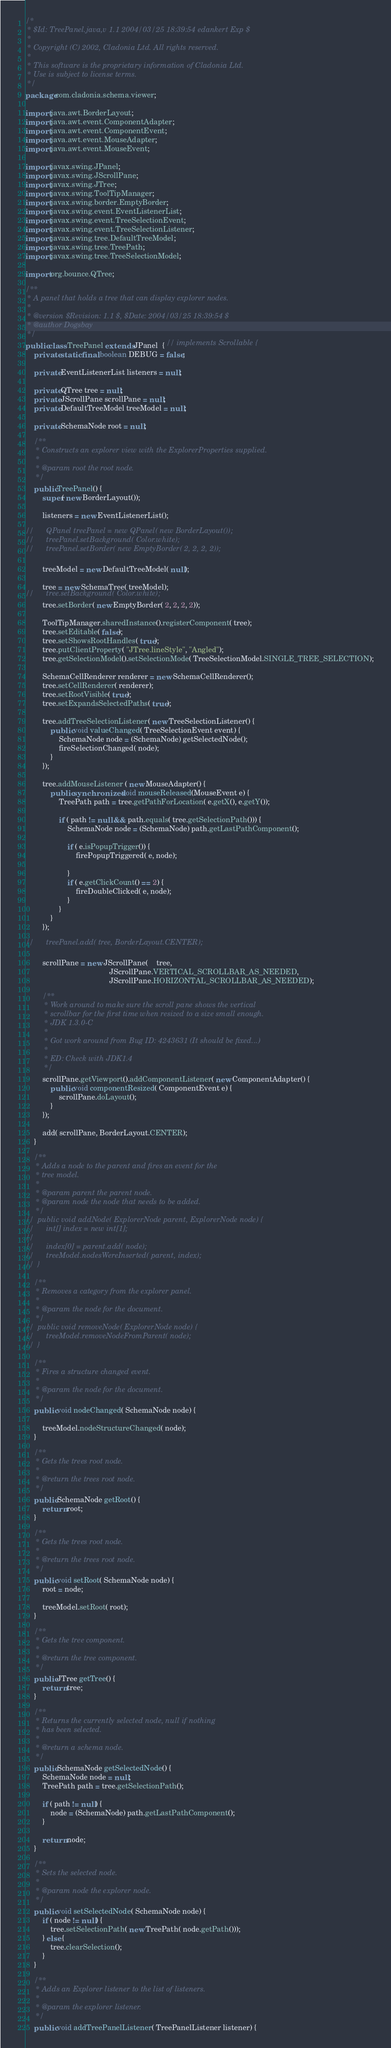<code> <loc_0><loc_0><loc_500><loc_500><_Java_>/*
 * $Id: TreePanel.java,v 1.1 2004/03/25 18:39:54 edankert Exp $
 *
 * Copyright (C) 2002, Cladonia Ltd. All rights reserved.
 *
 * This software is the proprietary information of Cladonia Ltd.  
 * Use is subject to license terms.
 */
package com.cladonia.schema.viewer;

import java.awt.BorderLayout;
import java.awt.event.ComponentAdapter;
import java.awt.event.ComponentEvent;
import java.awt.event.MouseAdapter;
import java.awt.event.MouseEvent;

import javax.swing.JPanel;
import javax.swing.JScrollPane;
import javax.swing.JTree;
import javax.swing.ToolTipManager;
import javax.swing.border.EmptyBorder;
import javax.swing.event.EventListenerList;
import javax.swing.event.TreeSelectionEvent;
import javax.swing.event.TreeSelectionListener;
import javax.swing.tree.DefaultTreeModel;
import javax.swing.tree.TreePath;
import javax.swing.tree.TreeSelectionModel;

import org.bounce.QTree;

/**
 * A panel that holds a tree that can display explorer nodes.
 *
 * @version	$Revision: 1.1 $, $Date: 2004/03/25 18:39:54 $
 * @author Dogsbay
 */
public class TreePanel extends JPanel  { // implements Scrollable {
	private static final boolean DEBUG = false;

	private EventListenerList listeners = null;

	private QTree tree = null;
	private JScrollPane scrollPane = null;
	private DefaultTreeModel treeModel = null;

	private SchemaNode root = null;

	/**
	 * Constructs an explorer view with the ExplorerProperties supplied.
	 *
	 * @param root the root node.
	 */
	public TreePanel() {
		super( new BorderLayout());
		
		listeners = new EventListenerList();
		
//		QPanel treePanel = new QPanel( new BorderLayout());
//		treePanel.setBackground( Color.white);
//		treePanel.setBorder( new EmptyBorder( 2, 2, 2, 2));

		treeModel = new DefaultTreeModel( null);

		tree = new SchemaTree( treeModel);
//		tree.setBackground( Color.white);
		tree.setBorder( new EmptyBorder( 2, 2, 2, 2));
		
		ToolTipManager.sharedInstance().registerComponent( tree);
		tree.setEditable( false);
		tree.setShowsRootHandles( true);
		tree.putClientProperty( "JTree.lineStyle", "Angled");
		tree.getSelectionModel().setSelectionMode( TreeSelectionModel.SINGLE_TREE_SELECTION);

		SchemaCellRenderer renderer = new SchemaCellRenderer();
		tree.setCellRenderer( renderer);
		tree.setRootVisible( true);
		tree.setExpandsSelectedPaths( true);

		tree.addTreeSelectionListener( new TreeSelectionListener() {
			public void valueChanged( TreeSelectionEvent event) {
				SchemaNode node = (SchemaNode) getSelectedNode();
				fireSelectionChanged( node);
			}
		});

		tree.addMouseListener ( new MouseAdapter() {
			public synchronized void mouseReleased(MouseEvent e) {
				TreePath path = tree.getPathForLocation( e.getX(), e.getY());

				if ( path != null && path.equals( tree.getSelectionPath())) {
					SchemaNode node = (SchemaNode) path.getLastPathComponent();
					
					if ( e.isPopupTrigger()) {
						firePopupTriggered( e, node);
						
					}
					if ( e.getClickCount() == 2) {
						fireDoubleClicked( e, node);
					}
				}
			}
		});
		
//		treePanel.add( tree, BorderLayout.CENTER);

		scrollPane = new JScrollPane(	tree,
										JScrollPane.VERTICAL_SCROLLBAR_AS_NEEDED,
										JScrollPane.HORIZONTAL_SCROLLBAR_AS_NEEDED);

		/**
		 * Work around to make sure the scroll pane shows the vertical 
		 * scrollbar for the first time when resized to a size small enough.
		 * JDK 1.3.0-C 
		 *
		 * Got work around from Bug ID: 4243631 (It should be fixed...)
		 *
		 * ED: Check with JDK1.4
		 */
		scrollPane.getViewport().addComponentListener( new ComponentAdapter() {
			public void componentResized( ComponentEvent e) {
				scrollPane.doLayout();
			}
		});
		
		add( scrollPane, BorderLayout.CENTER);
	}
	
	/**
	 * Adds a node to the parent and fires an event for the 
	 * tree model.
	 *
	 * @param parent the parent node.
	 * @param node the node that needs to be added.
	 */
//	public void addNode( ExplorerNode parent, ExplorerNode node) {
//		int[] index = new int[1];
//
//		index[0] = parent.add( node);
//		treeModel.nodesWereInserted( parent, index);
//	}

	/**
	 * Removes a category from the explorer panel.
	 *
	 * @param the node for the document.
	 */
//	public void removeNode( ExplorerNode node) {
//		treeModel.removeNodeFromParent( node);
//	}

	/**
	 * Fires a structure changed event.
	 *
	 * @param the node for the document.
	 */
	public void nodeChanged( SchemaNode node) {
	
		treeModel.nodeStructureChanged( node);
	}

	/**
	 * Gets the trees root node.
	 *
	 * @return the trees root node.
	 */
	public SchemaNode getRoot() {
		return root;
	}

	/**
	 * Gets the trees root node.
	 *
	 * @return the trees root node.
	 */
	public void setRoot( SchemaNode node) {
		root = node;
		
		treeModel.setRoot( root);
	}

	/**
	 * Gets the tree component.
	 *
	 * @return the tree component.
	 */
	public JTree getTree() {
		return tree;
	}

	/**
	 * Returns the currently selected node, null if nothing 
	 * has been selected.
	 *
	 * @return a schema node.
	 */
	public SchemaNode getSelectedNode() {
		SchemaNode node = null;
		TreePath path = tree.getSelectionPath();
		
		if ( path != null) {
			node = (SchemaNode) path.getLastPathComponent();
		}	
	
		return node;
	}

	/**
	 * Sets the selected node.
	 *
	 * @param node the explorer node.
	 */
	public void setSelectedNode( SchemaNode node) {
		if ( node != null) {
			tree.setSelectionPath( new TreePath( node.getPath()));
		} else {
			tree.clearSelection();
		}
	}

	/** 
	 * Adds an Explorer listener to the list of listeners.
	 *
	 * @param the explorer listener.
	 */
	public void addTreePanelListener( TreePanelListener listener) {</code> 